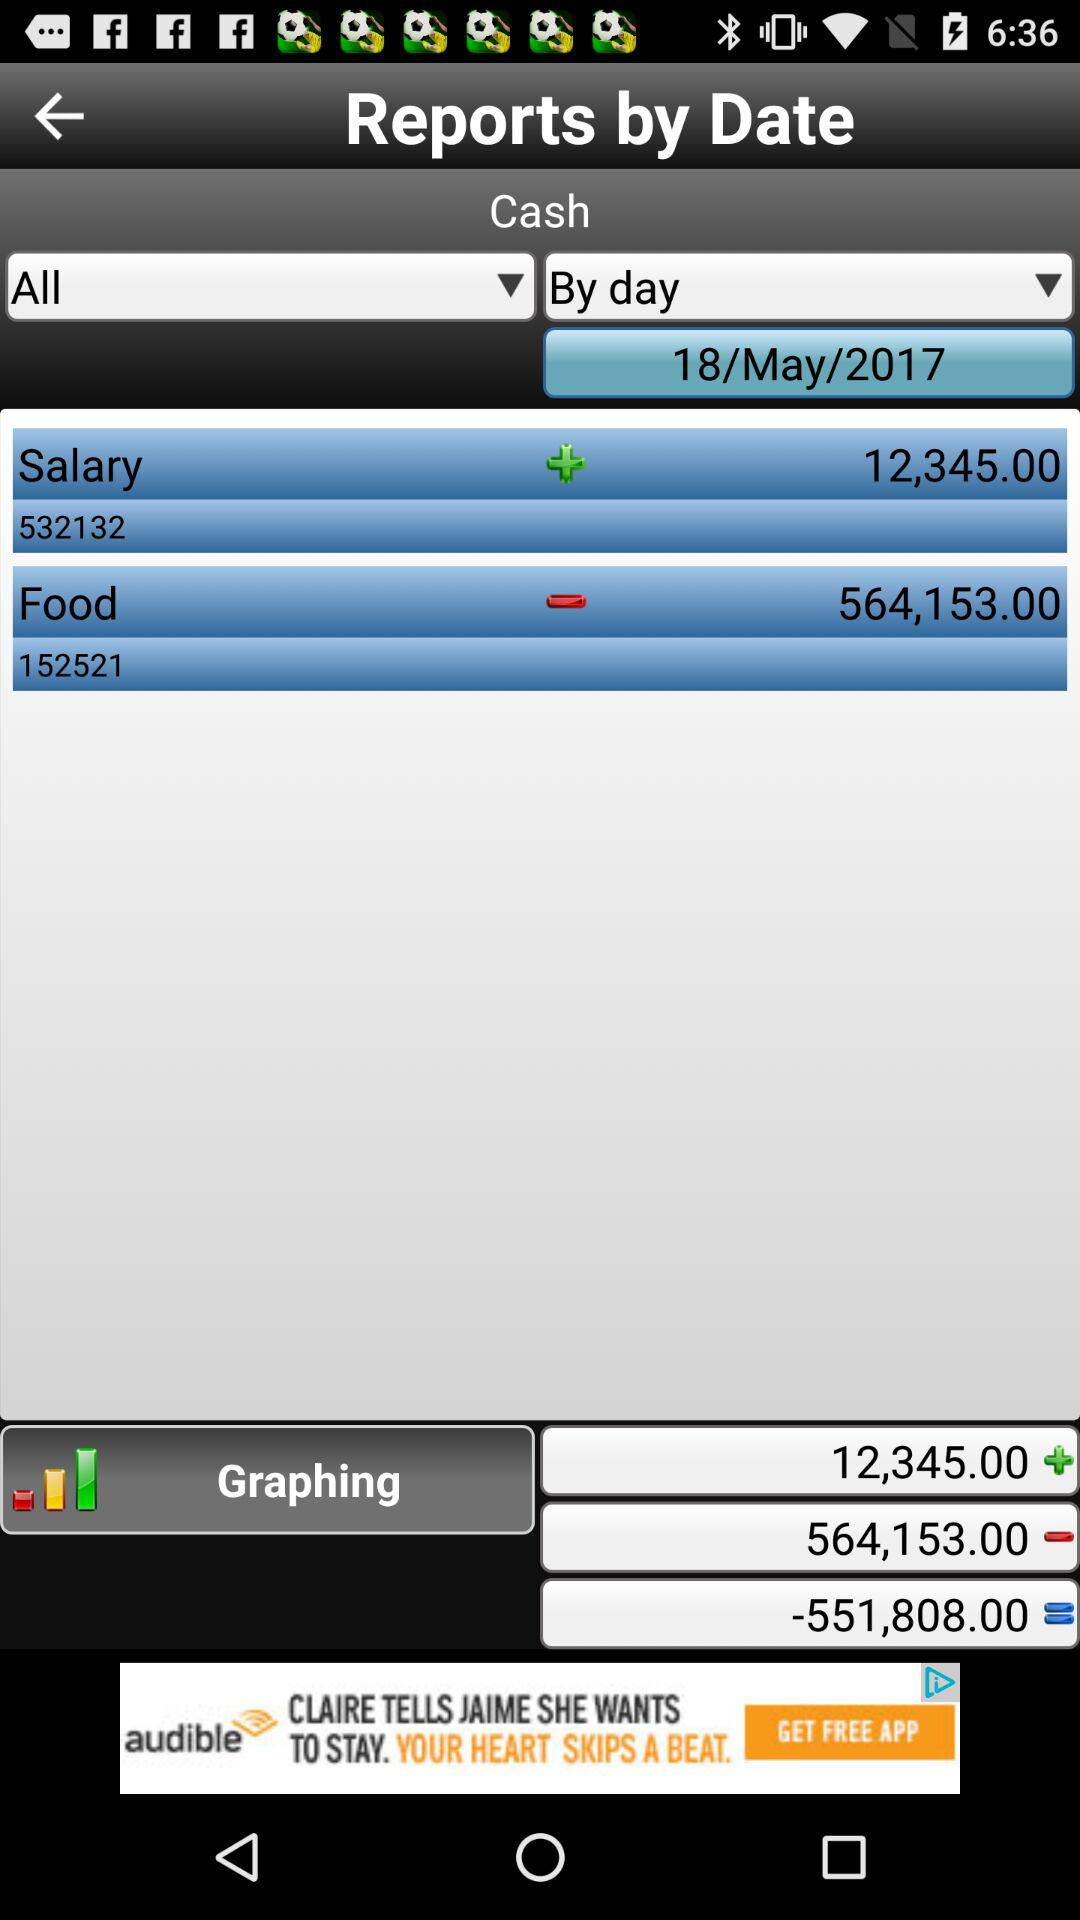What item amount is subtracted from the main amount? The food item's amount is subtracted from the main amount. 